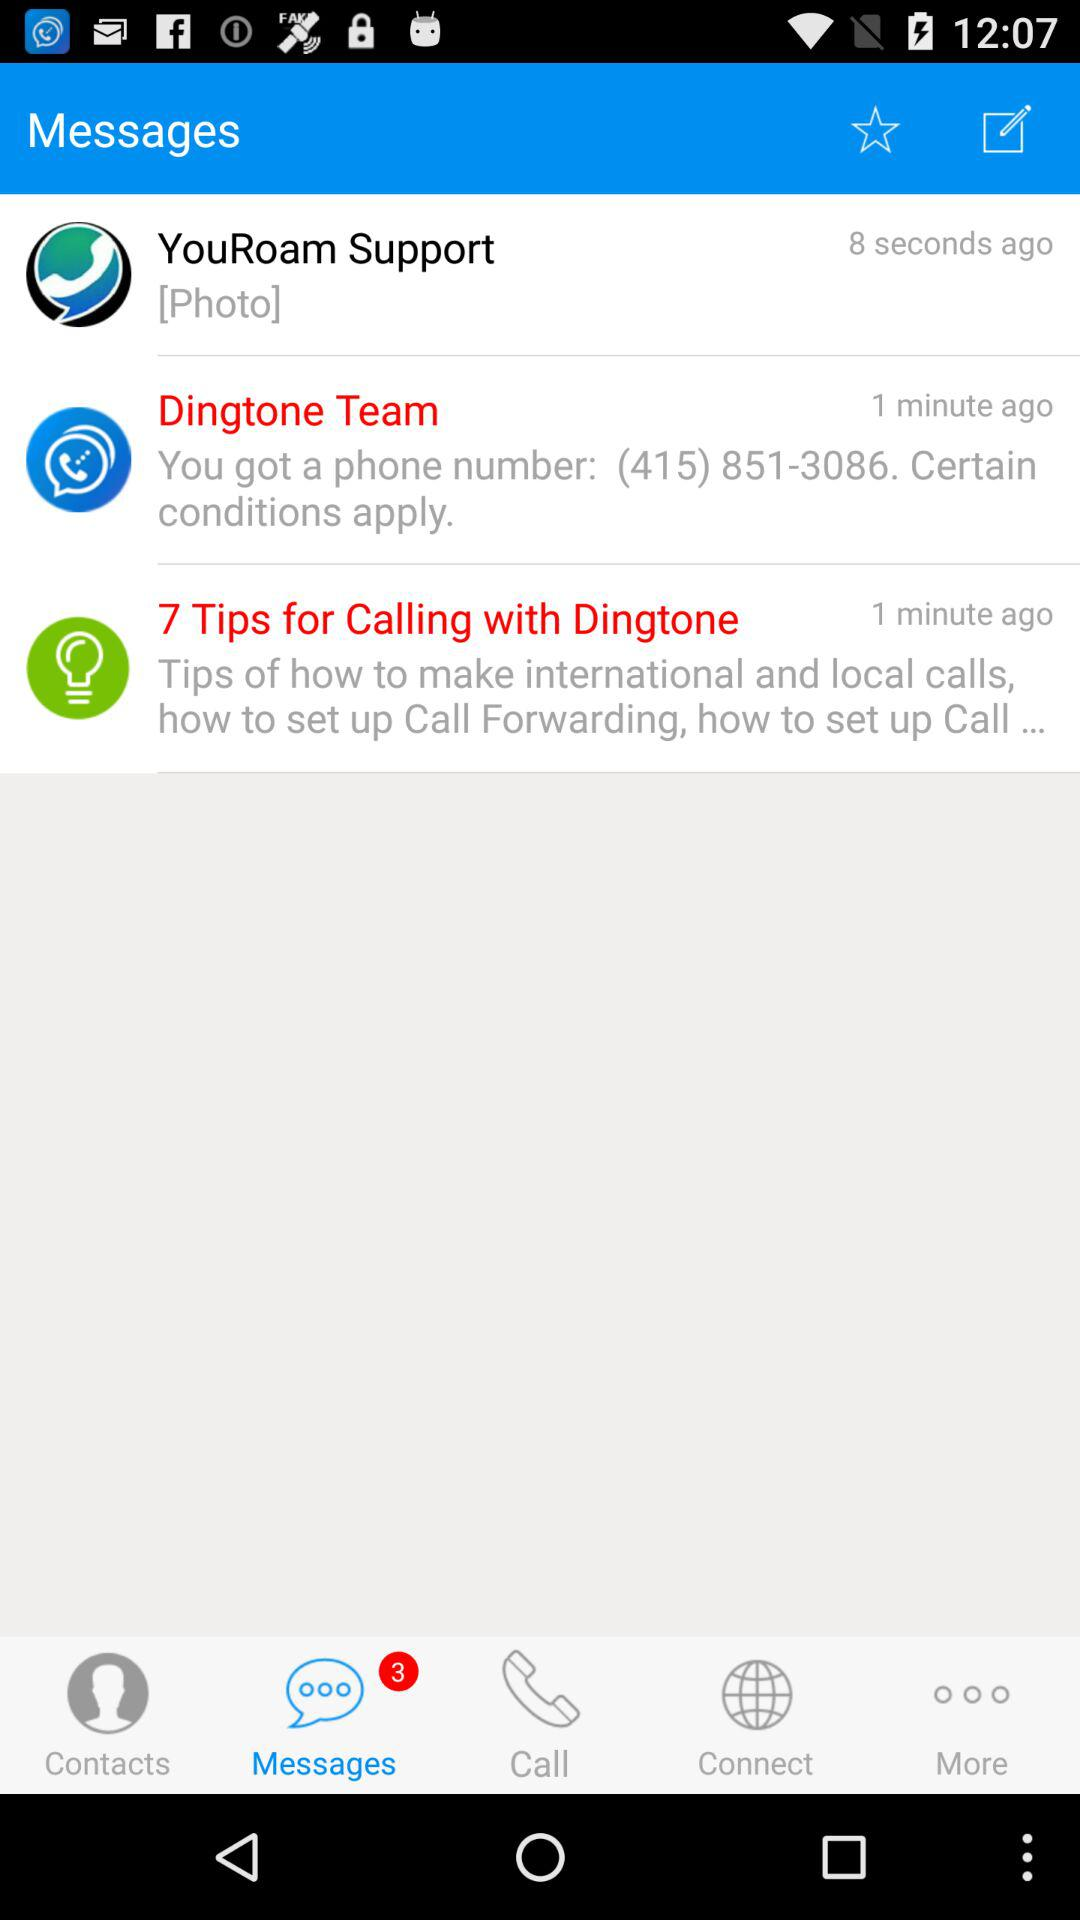Which tab is selected? The selected tab is "Messages". 